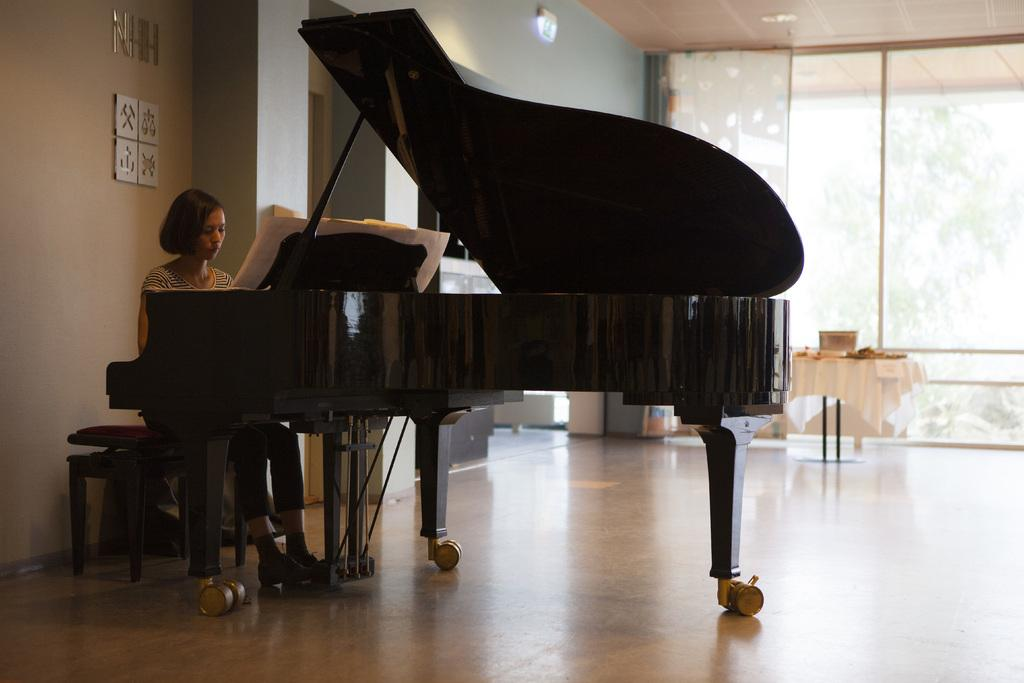What is the girl doing in the image? The girl is sitting in front of a piano in the image. What can be seen in the background of the image? There are glass windows, trees, a table, and other objects in the background of the image. What type of fowl is sitting on the piano in the image? There is no fowl present on the piano in the image. How many letters are visible on the piano in the image? There are no letters visible on the piano in the image. 